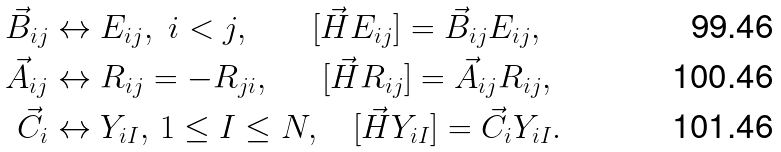<formula> <loc_0><loc_0><loc_500><loc_500>\vec { B } _ { i j } & \leftrightarrow E _ { i j } , \ i < j , \ \quad \ \ [ \vec { H } E _ { i j } ] = \vec { B } _ { i j } E _ { i j } , \\ \vec { A } _ { i j } & \leftrightarrow R _ { i j } = - R _ { j i } , \ \quad \ [ \vec { H } R _ { i j } ] = \vec { A } _ { i j } R _ { i j } , \\ \vec { C } _ { i } & \leftrightarrow Y _ { i I } , \, 1 \leq I \leq N , \quad [ \vec { H } Y _ { i I } ] = \vec { C } _ { i } Y _ { i I } .</formula> 